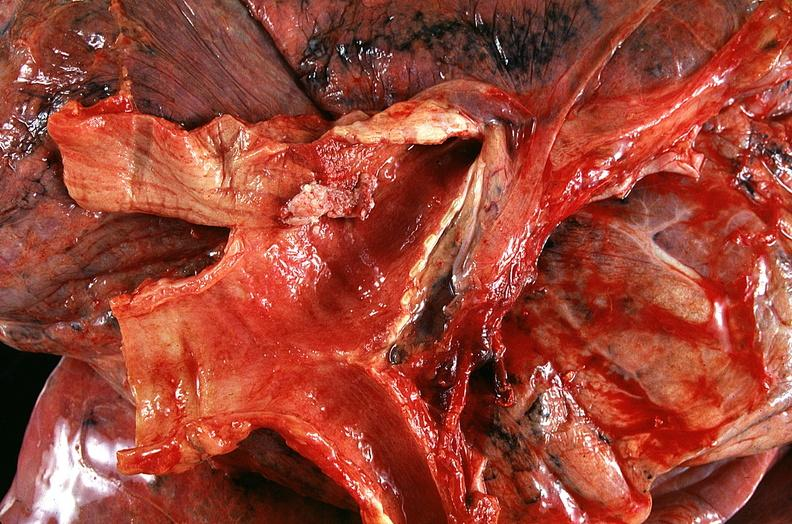what is present?
Answer the question using a single word or phrase. Respiratory 